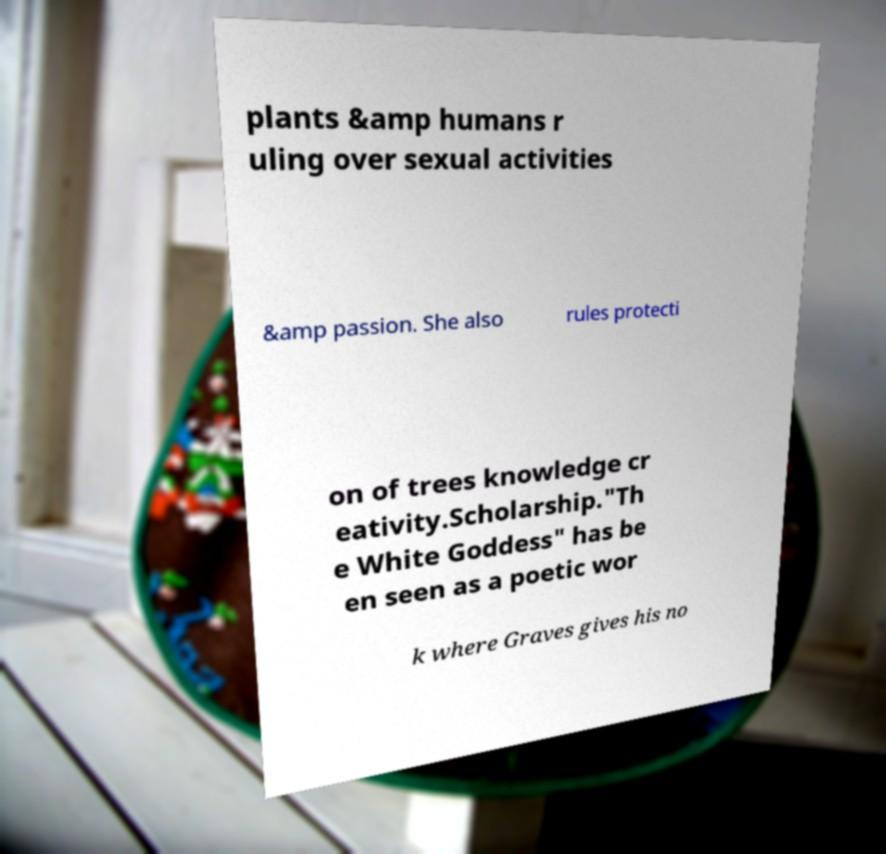Can you accurately transcribe the text from the provided image for me? plants &amp humans r uling over sexual activities &amp passion. She also rules protecti on of trees knowledge cr eativity.Scholarship."Th e White Goddess" has be en seen as a poetic wor k where Graves gives his no 